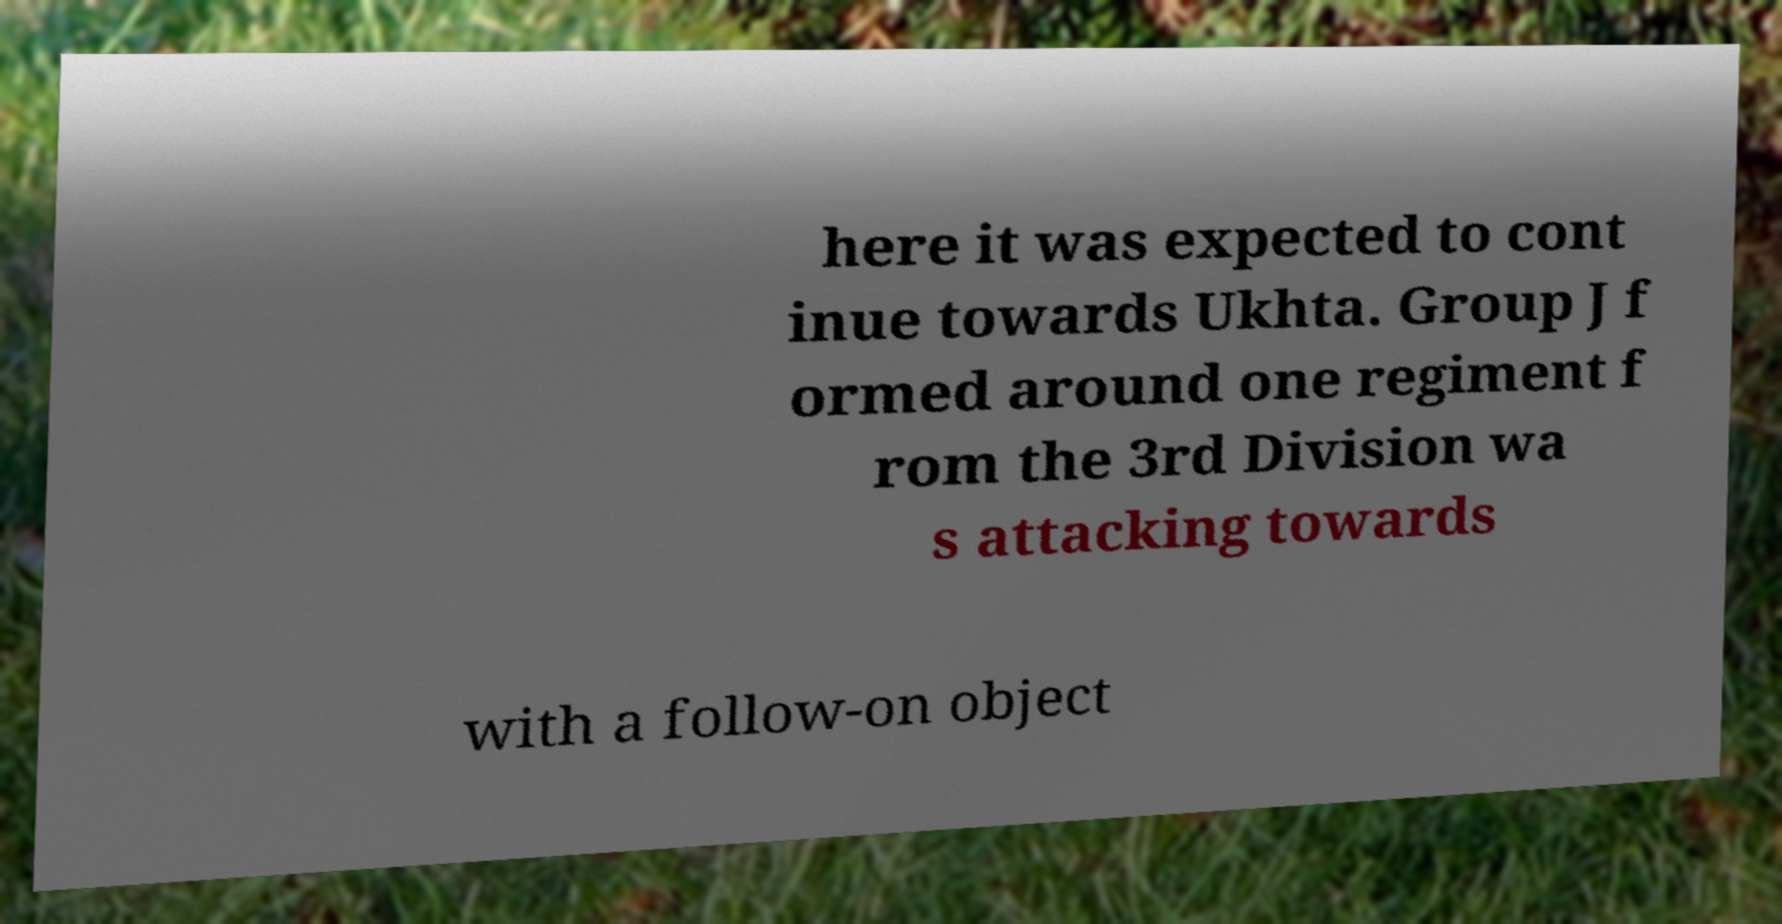Please identify and transcribe the text found in this image. here it was expected to cont inue towards Ukhta. Group J f ormed around one regiment f rom the 3rd Division wa s attacking towards with a follow-on object 